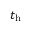Convert formula to latex. <formula><loc_0><loc_0><loc_500><loc_500>t _ { h }</formula> 